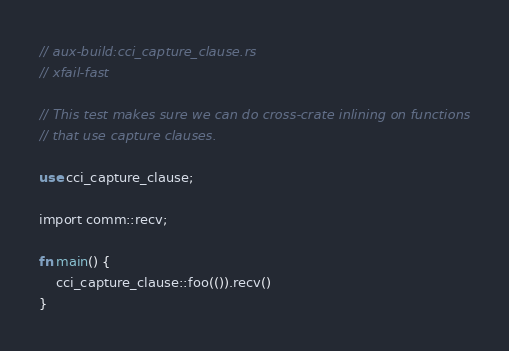<code> <loc_0><loc_0><loc_500><loc_500><_Rust_>// aux-build:cci_capture_clause.rs
// xfail-fast

// This test makes sure we can do cross-crate inlining on functions
// that use capture clauses.

use cci_capture_clause;

import comm::recv;

fn main() {
    cci_capture_clause::foo(()).recv()
}
</code> 